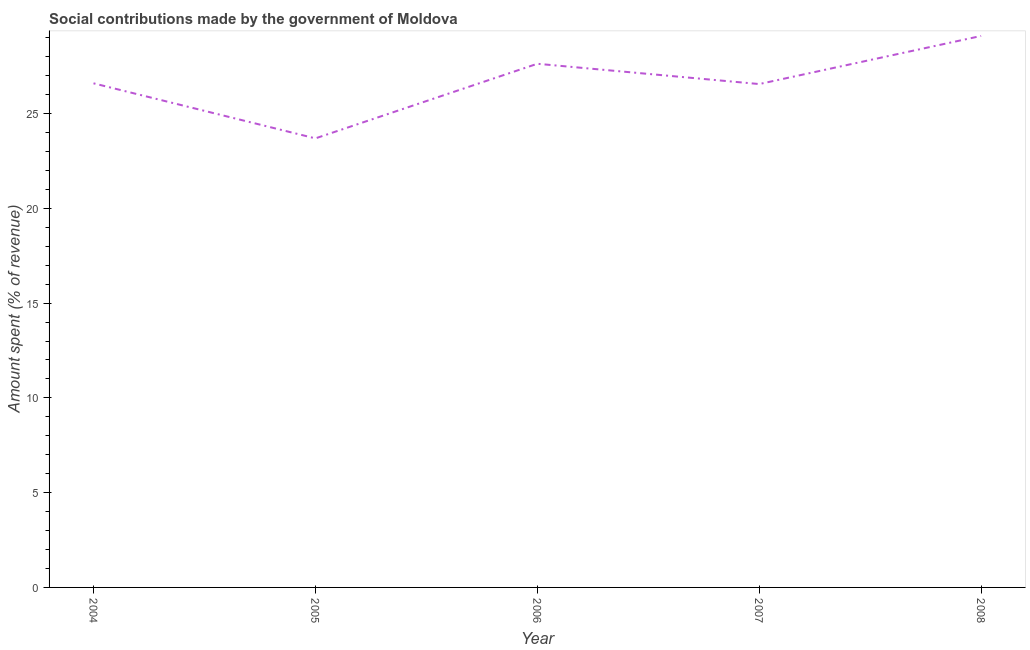What is the amount spent in making social contributions in 2006?
Offer a very short reply. 27.63. Across all years, what is the maximum amount spent in making social contributions?
Keep it short and to the point. 29.1. Across all years, what is the minimum amount spent in making social contributions?
Offer a terse response. 23.69. In which year was the amount spent in making social contributions maximum?
Ensure brevity in your answer.  2008. What is the sum of the amount spent in making social contributions?
Make the answer very short. 133.57. What is the difference between the amount spent in making social contributions in 2007 and 2008?
Offer a very short reply. -2.54. What is the average amount spent in making social contributions per year?
Keep it short and to the point. 26.71. What is the median amount spent in making social contributions?
Your answer should be very brief. 26.6. In how many years, is the amount spent in making social contributions greater than 22 %?
Your answer should be very brief. 5. Do a majority of the years between 2005 and 2007 (inclusive) have amount spent in making social contributions greater than 16 %?
Your answer should be very brief. Yes. What is the ratio of the amount spent in making social contributions in 2004 to that in 2006?
Give a very brief answer. 0.96. Is the difference between the amount spent in making social contributions in 2004 and 2006 greater than the difference between any two years?
Provide a short and direct response. No. What is the difference between the highest and the second highest amount spent in making social contributions?
Offer a very short reply. 1.47. Is the sum of the amount spent in making social contributions in 2007 and 2008 greater than the maximum amount spent in making social contributions across all years?
Ensure brevity in your answer.  Yes. What is the difference between the highest and the lowest amount spent in making social contributions?
Offer a terse response. 5.4. In how many years, is the amount spent in making social contributions greater than the average amount spent in making social contributions taken over all years?
Make the answer very short. 2. How many lines are there?
Offer a very short reply. 1. Are the values on the major ticks of Y-axis written in scientific E-notation?
Keep it short and to the point. No. Does the graph contain any zero values?
Ensure brevity in your answer.  No. Does the graph contain grids?
Keep it short and to the point. No. What is the title of the graph?
Offer a terse response. Social contributions made by the government of Moldova. What is the label or title of the Y-axis?
Ensure brevity in your answer.  Amount spent (% of revenue). What is the Amount spent (% of revenue) of 2004?
Your answer should be compact. 26.6. What is the Amount spent (% of revenue) of 2005?
Make the answer very short. 23.69. What is the Amount spent (% of revenue) in 2006?
Keep it short and to the point. 27.63. What is the Amount spent (% of revenue) of 2007?
Ensure brevity in your answer.  26.56. What is the Amount spent (% of revenue) in 2008?
Provide a short and direct response. 29.1. What is the difference between the Amount spent (% of revenue) in 2004 and 2005?
Make the answer very short. 2.9. What is the difference between the Amount spent (% of revenue) in 2004 and 2006?
Keep it short and to the point. -1.03. What is the difference between the Amount spent (% of revenue) in 2004 and 2007?
Offer a very short reply. 0.04. What is the difference between the Amount spent (% of revenue) in 2004 and 2008?
Your answer should be very brief. -2.5. What is the difference between the Amount spent (% of revenue) in 2005 and 2006?
Offer a terse response. -3.94. What is the difference between the Amount spent (% of revenue) in 2005 and 2007?
Offer a terse response. -2.87. What is the difference between the Amount spent (% of revenue) in 2005 and 2008?
Your answer should be compact. -5.4. What is the difference between the Amount spent (% of revenue) in 2006 and 2007?
Keep it short and to the point. 1.07. What is the difference between the Amount spent (% of revenue) in 2006 and 2008?
Give a very brief answer. -1.47. What is the difference between the Amount spent (% of revenue) in 2007 and 2008?
Give a very brief answer. -2.54. What is the ratio of the Amount spent (% of revenue) in 2004 to that in 2005?
Provide a succinct answer. 1.12. What is the ratio of the Amount spent (% of revenue) in 2004 to that in 2007?
Give a very brief answer. 1. What is the ratio of the Amount spent (% of revenue) in 2004 to that in 2008?
Keep it short and to the point. 0.91. What is the ratio of the Amount spent (% of revenue) in 2005 to that in 2006?
Make the answer very short. 0.86. What is the ratio of the Amount spent (% of revenue) in 2005 to that in 2007?
Give a very brief answer. 0.89. What is the ratio of the Amount spent (% of revenue) in 2005 to that in 2008?
Your answer should be very brief. 0.81. What is the ratio of the Amount spent (% of revenue) in 2007 to that in 2008?
Your response must be concise. 0.91. 